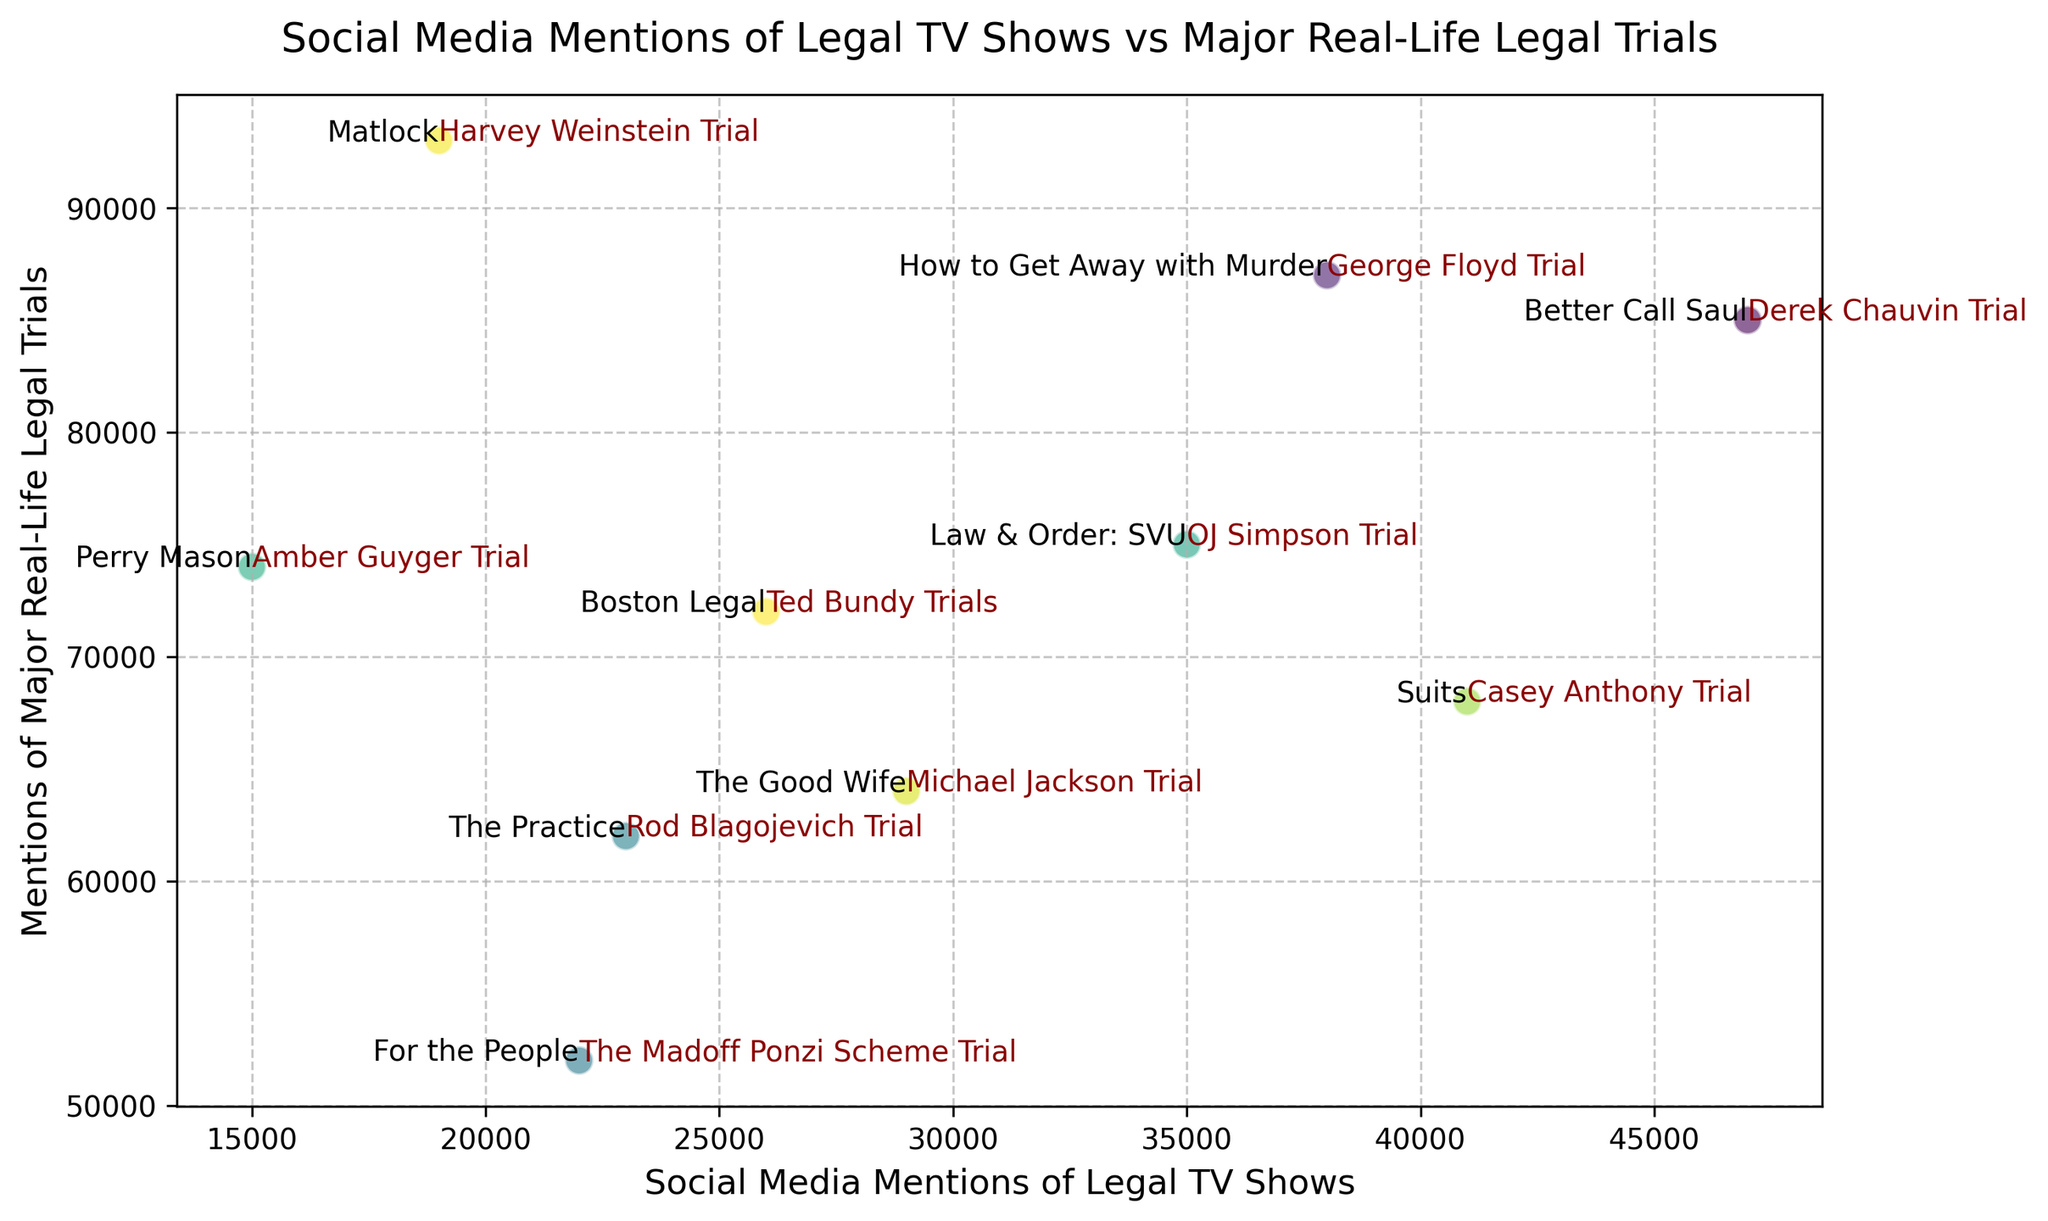"Which legal TV show has the most social media mentions?" To identify the TV show with the highest social media mentions, look for the data point with the highest value on the x-axis. "Better Call Saul" is positioned furthest right, indicating it has the most mentions.
Answer: "Better Call Saul" "What is the difference in social media mentions between 'Law & Order: SVU' and 'Matlock'?" First, locate both TV shows on the x-axis. 'Law & Order: SVU' has 35000 mentions, and 'Matlock' has 19000 mentions. Subtract 19000 from 35000 to find the difference.
Answer: 16000 "Which major real-life trial received the highest number of mentions?" To determine this, examine the y-axis for the data point positioned highest. The 'Harvey Weinstein Trial' reaches the highest point on the y-axis, reflecting the most mentions.
Answer: "Harvey Weinstein Trial" "Are social media mentions of 'Better Call Saul' greater than those of 'Perry Mason'?" Find both shows on the x-axis. 'Better Call Saul' (47000) is to the right of 'Perry Mason' (15000), indicating it has more social media mentions.
Answer: Yes "What is the average social media mention count for the TV shows 'Suits', 'Better Call Saul', and 'How to Get Away with Murder'?" The mentions are 41000, 47000, and 38000, respectively. Calculate the average: (41000 + 47000 + 38000) / 3 = 126000 / 3 = 42000.
Answer: 42000 "Which real-life trial had fewer social media mentions: the 'Ted Bundy Trials' or the 'Michael Jackson Trial'?" Compare their positions on the y-axis. The 'Ted Bundy Trials' (72000) are lower than the 'Michael Jackson Trial' (64000).
Answer: "Ted Bundy Trials" "What is the sum of social media mentions for 'Boston Legal' and 'Perry Mason'?" Locate their counts: 'Boston Legal' has 26000 mentions and 'Perry Mason' has 15000. Adding these gives 26000 + 15000 = 41000.
Answer: 41000 "Which TV show has more social media mentions, 'The Good Wife' or 'The Practice'?" Compare their positions on the x-axis. 'The Good Wife' (29000) is to the right of 'The Practice' (23000), indicating it has more mentions.
Answer: "The Good Wife" "Does 'George Floyd Trial' have more mentions than the 'OJ Simpson Trial'?" Locate these trials on the y-axis. The 'George Floyd Trial' (87000) is above the 'OJ Simpson Trial' (75000), indicating it has more mentions.
Answer: Yes "What is the difference in real-life trial mentions between 'The Madoff Ponzi Scheme Trial' and the 'Rod Blagojevich Trial'?" Identify their y-values: 'The Madoff Ponzi Scheme Trial' has 52000 mentions and 'Rod Blagojevich Trial' has 62000 mentions. Subtract 52000 from 62000 to find the difference.
Answer: 10000 